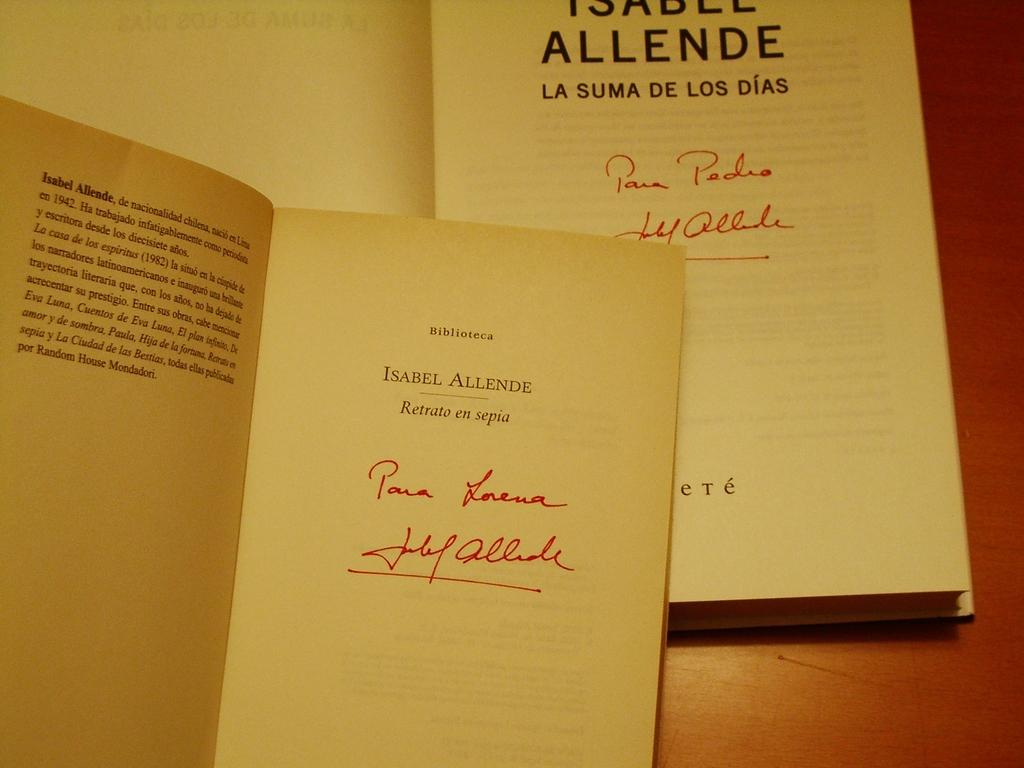<image>
Create a compact narrative representing the image presented. A book is open to the title page and the title Isabel Allende is shown above handwriting. 